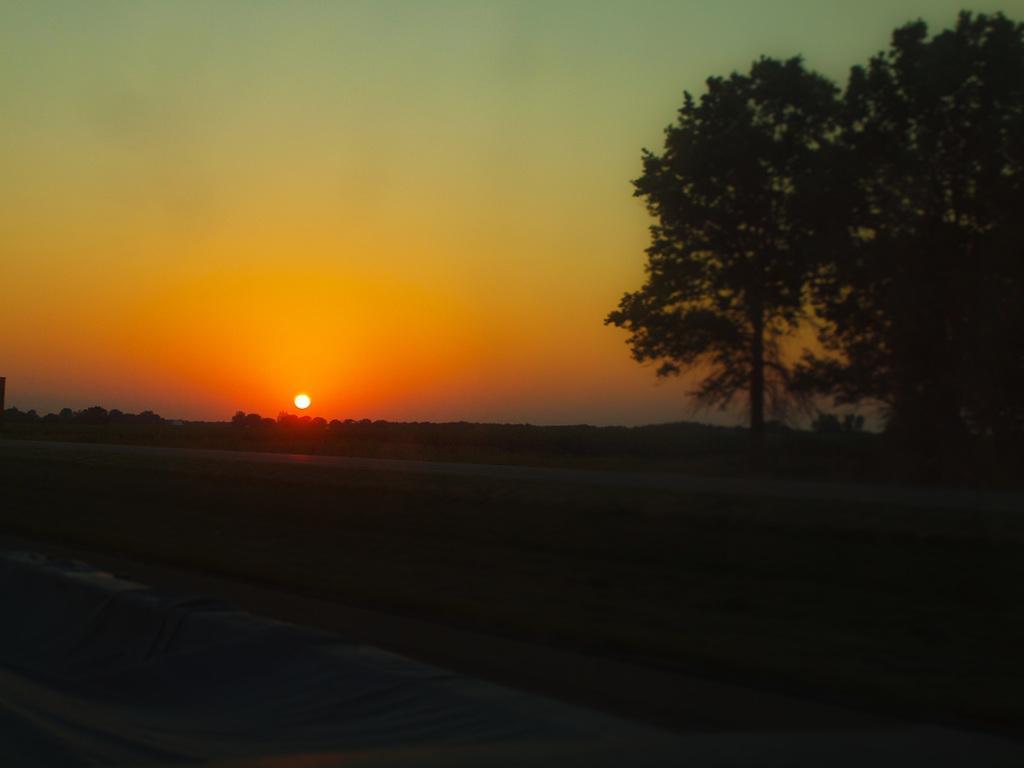Please provide a concise description of this image. This image is a dark image. In this image we can see there are trees. In the background we can see the sun and sky.  